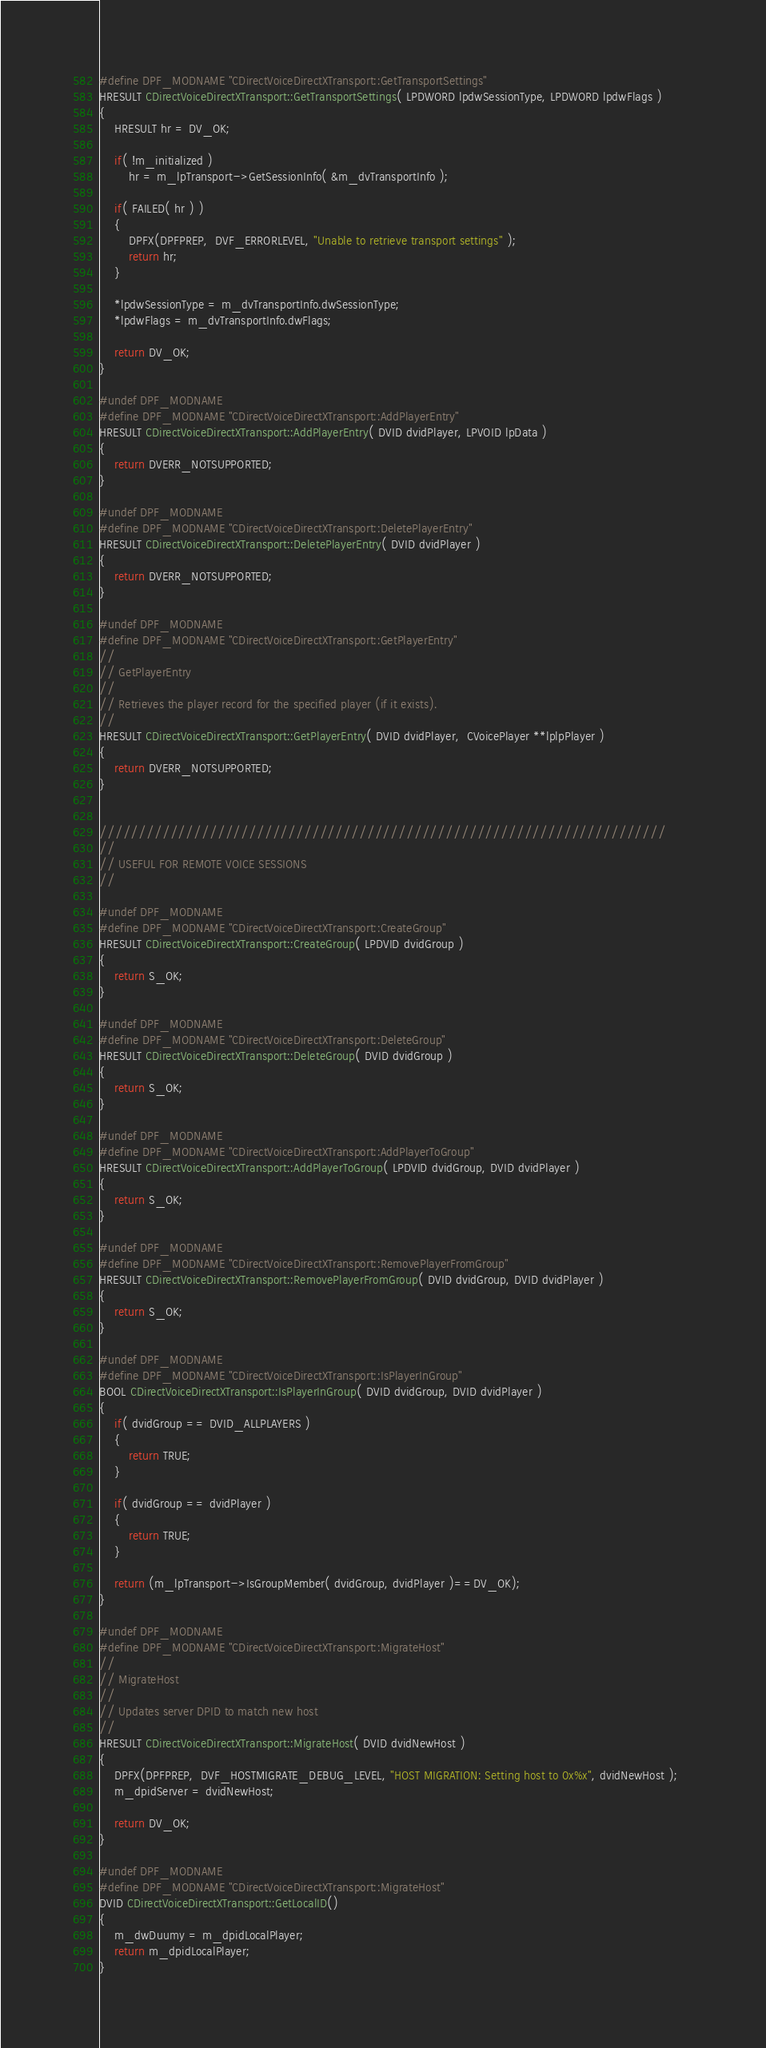<code> <loc_0><loc_0><loc_500><loc_500><_C++_>#define DPF_MODNAME "CDirectVoiceDirectXTransport::GetTransportSettings"
HRESULT CDirectVoiceDirectXTransport::GetTransportSettings( LPDWORD lpdwSessionType, LPDWORD lpdwFlags )
{
	HRESULT hr = DV_OK;
	
	if( !m_initialized )
		hr = m_lpTransport->GetSessionInfo( &m_dvTransportInfo );

	if( FAILED( hr ) )
	{
		DPFX(DPFPREP,  DVF_ERRORLEVEL, "Unable to retrieve transport settings" );
		return hr;
	}

	*lpdwSessionType = m_dvTransportInfo.dwSessionType;
	*lpdwFlags = m_dvTransportInfo.dwFlags;

	return DV_OK;
}

#undef DPF_MODNAME
#define DPF_MODNAME "CDirectVoiceDirectXTransport::AddPlayerEntry"
HRESULT CDirectVoiceDirectXTransport::AddPlayerEntry( DVID dvidPlayer, LPVOID lpData )
{
	return DVERR_NOTSUPPORTED;
}

#undef DPF_MODNAME
#define DPF_MODNAME "CDirectVoiceDirectXTransport::DeletePlayerEntry"
HRESULT CDirectVoiceDirectXTransport::DeletePlayerEntry( DVID dvidPlayer )
{
	return DVERR_NOTSUPPORTED;
}

#undef DPF_MODNAME
#define DPF_MODNAME "CDirectVoiceDirectXTransport::GetPlayerEntry"
//
// GetPlayerEntry
//
// Retrieves the player record for the specified player (if it exists).
//
HRESULT CDirectVoiceDirectXTransport::GetPlayerEntry( DVID dvidPlayer,  CVoicePlayer **lplpPlayer )
{
	return DVERR_NOTSUPPORTED;
}


////////////////////////////////////////////////////////////////////////
//
// USEFUL FOR REMOTE VOICE SESSIONS
//

#undef DPF_MODNAME
#define DPF_MODNAME "CDirectVoiceDirectXTransport::CreateGroup"
HRESULT CDirectVoiceDirectXTransport::CreateGroup( LPDVID dvidGroup )
{
	return S_OK;
}

#undef DPF_MODNAME
#define DPF_MODNAME "CDirectVoiceDirectXTransport::DeleteGroup"
HRESULT CDirectVoiceDirectXTransport::DeleteGroup( DVID dvidGroup )
{
	return S_OK;
}

#undef DPF_MODNAME
#define DPF_MODNAME "CDirectVoiceDirectXTransport::AddPlayerToGroup"
HRESULT CDirectVoiceDirectXTransport::AddPlayerToGroup( LPDVID dvidGroup, DVID dvidPlayer )
{
	return S_OK;
}

#undef DPF_MODNAME
#define DPF_MODNAME "CDirectVoiceDirectXTransport::RemovePlayerFromGroup"
HRESULT CDirectVoiceDirectXTransport::RemovePlayerFromGroup( DVID dvidGroup, DVID dvidPlayer )
{
	return S_OK;
}

#undef DPF_MODNAME
#define DPF_MODNAME "CDirectVoiceDirectXTransport::IsPlayerInGroup"
BOOL CDirectVoiceDirectXTransport::IsPlayerInGroup( DVID dvidGroup, DVID dvidPlayer )
{
	if( dvidGroup == DVID_ALLPLAYERS )
	{
		return TRUE;
	}

	if( dvidGroup == dvidPlayer )
	{
		return TRUE;
	}

	return (m_lpTransport->IsGroupMember( dvidGroup, dvidPlayer )==DV_OK);
}

#undef DPF_MODNAME
#define DPF_MODNAME "CDirectVoiceDirectXTransport::MigrateHost"
//
// MigrateHost
//
// Updates server DPID to match new host
//
HRESULT CDirectVoiceDirectXTransport::MigrateHost( DVID dvidNewHost )
{
	DPFX(DPFPREP,  DVF_HOSTMIGRATE_DEBUG_LEVEL, "HOST MIGRATION: Setting host to 0x%x", dvidNewHost );	
	m_dpidServer = dvidNewHost;

	return DV_OK;
}

#undef DPF_MODNAME
#define DPF_MODNAME "CDirectVoiceDirectXTransport::MigrateHost"
DVID CDirectVoiceDirectXTransport::GetLocalID() 
{ 
    m_dwDuumy = m_dpidLocalPlayer;
    return m_dpidLocalPlayer; 
}


</code> 